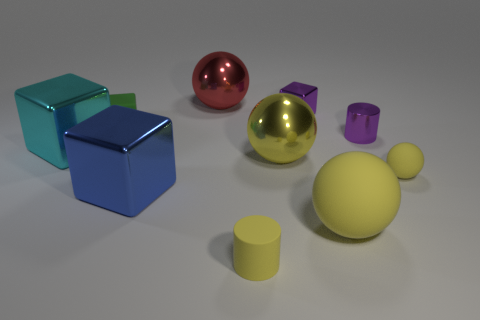Is the rubber cylinder the same size as the purple cylinder?
Provide a succinct answer. Yes. What size is the rubber object that is behind the small rubber thing to the right of the tiny purple cylinder?
Offer a very short reply. Small. How many big objects are in front of the small rubber block and behind the purple cylinder?
Your answer should be compact. 0. There is a yellow rubber object on the left side of the small purple metallic object behind the green rubber object; are there any big cyan blocks in front of it?
Offer a very short reply. No. What is the shape of the cyan thing that is the same size as the blue block?
Keep it short and to the point. Cube. Is there a large sphere of the same color as the big rubber thing?
Your answer should be compact. Yes. Is the large cyan metal thing the same shape as the large yellow metal object?
Your answer should be very brief. No. How many big things are either red metal blocks or metallic cylinders?
Ensure brevity in your answer.  0. What is the color of the tiny cylinder that is made of the same material as the big cyan cube?
Offer a very short reply. Purple. How many large blocks have the same material as the blue object?
Offer a terse response. 1. 